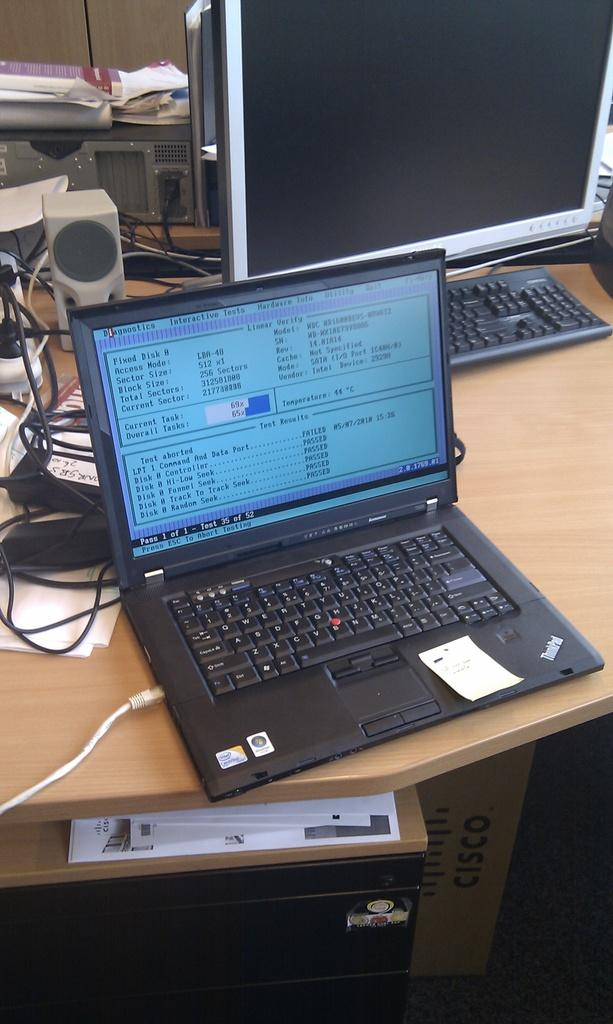<image>
Share a concise interpretation of the image provided. A laptop is open to a screen that says "Diagnostics" at the upper left. 